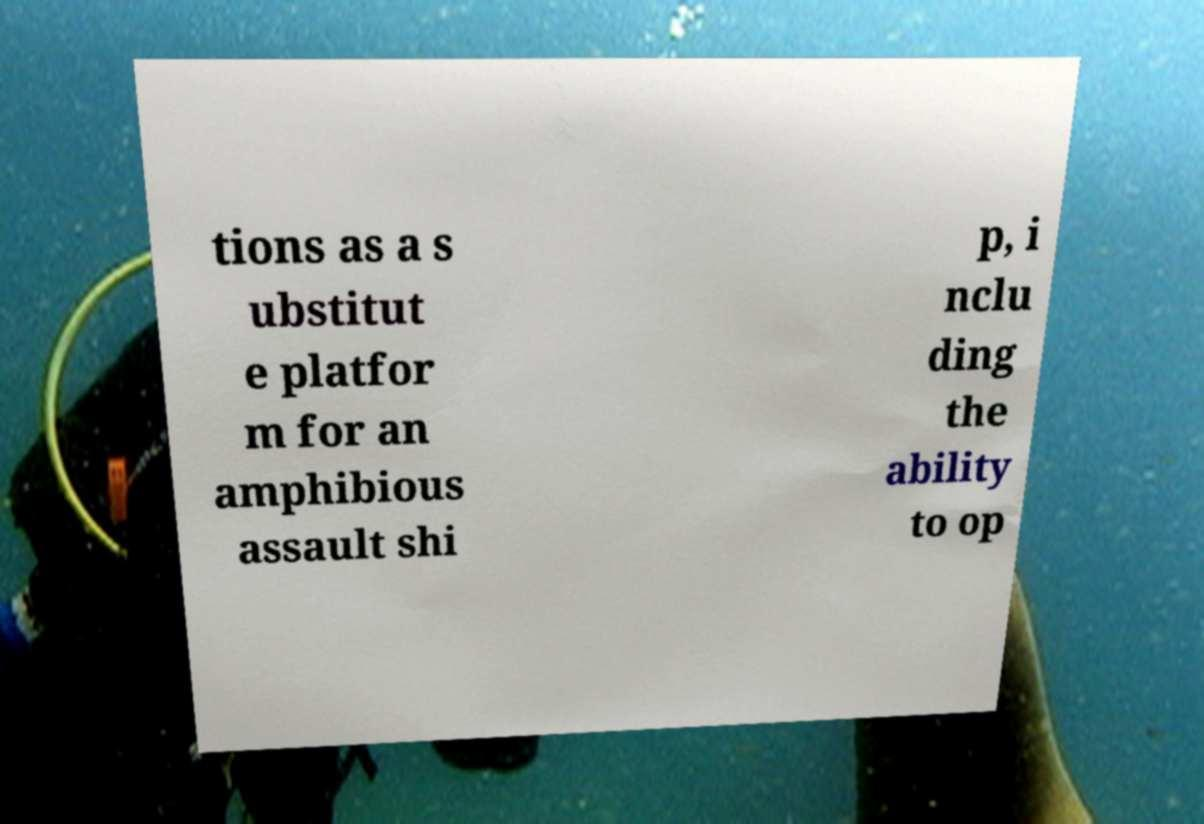Could you extract and type out the text from this image? tions as a s ubstitut e platfor m for an amphibious assault shi p, i nclu ding the ability to op 